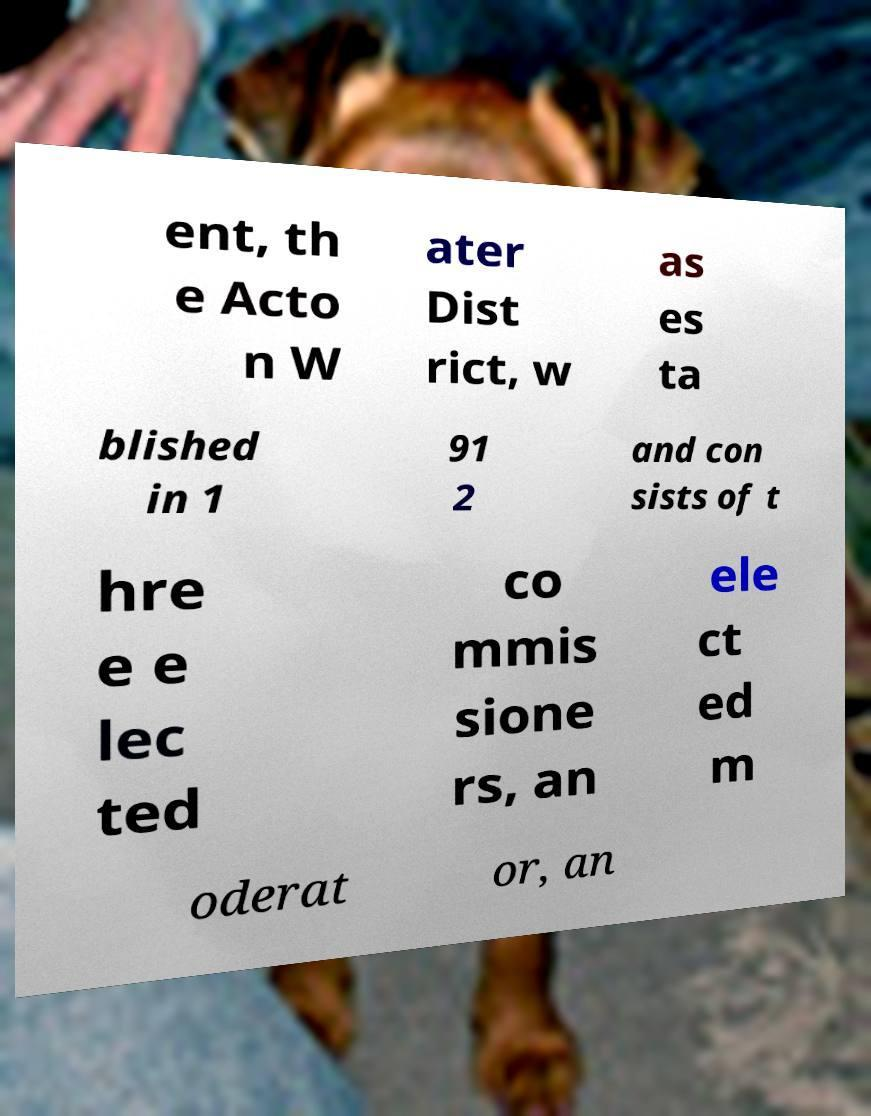For documentation purposes, I need the text within this image transcribed. Could you provide that? ent, th e Acto n W ater Dist rict, w as es ta blished in 1 91 2 and con sists of t hre e e lec ted co mmis sione rs, an ele ct ed m oderat or, an 